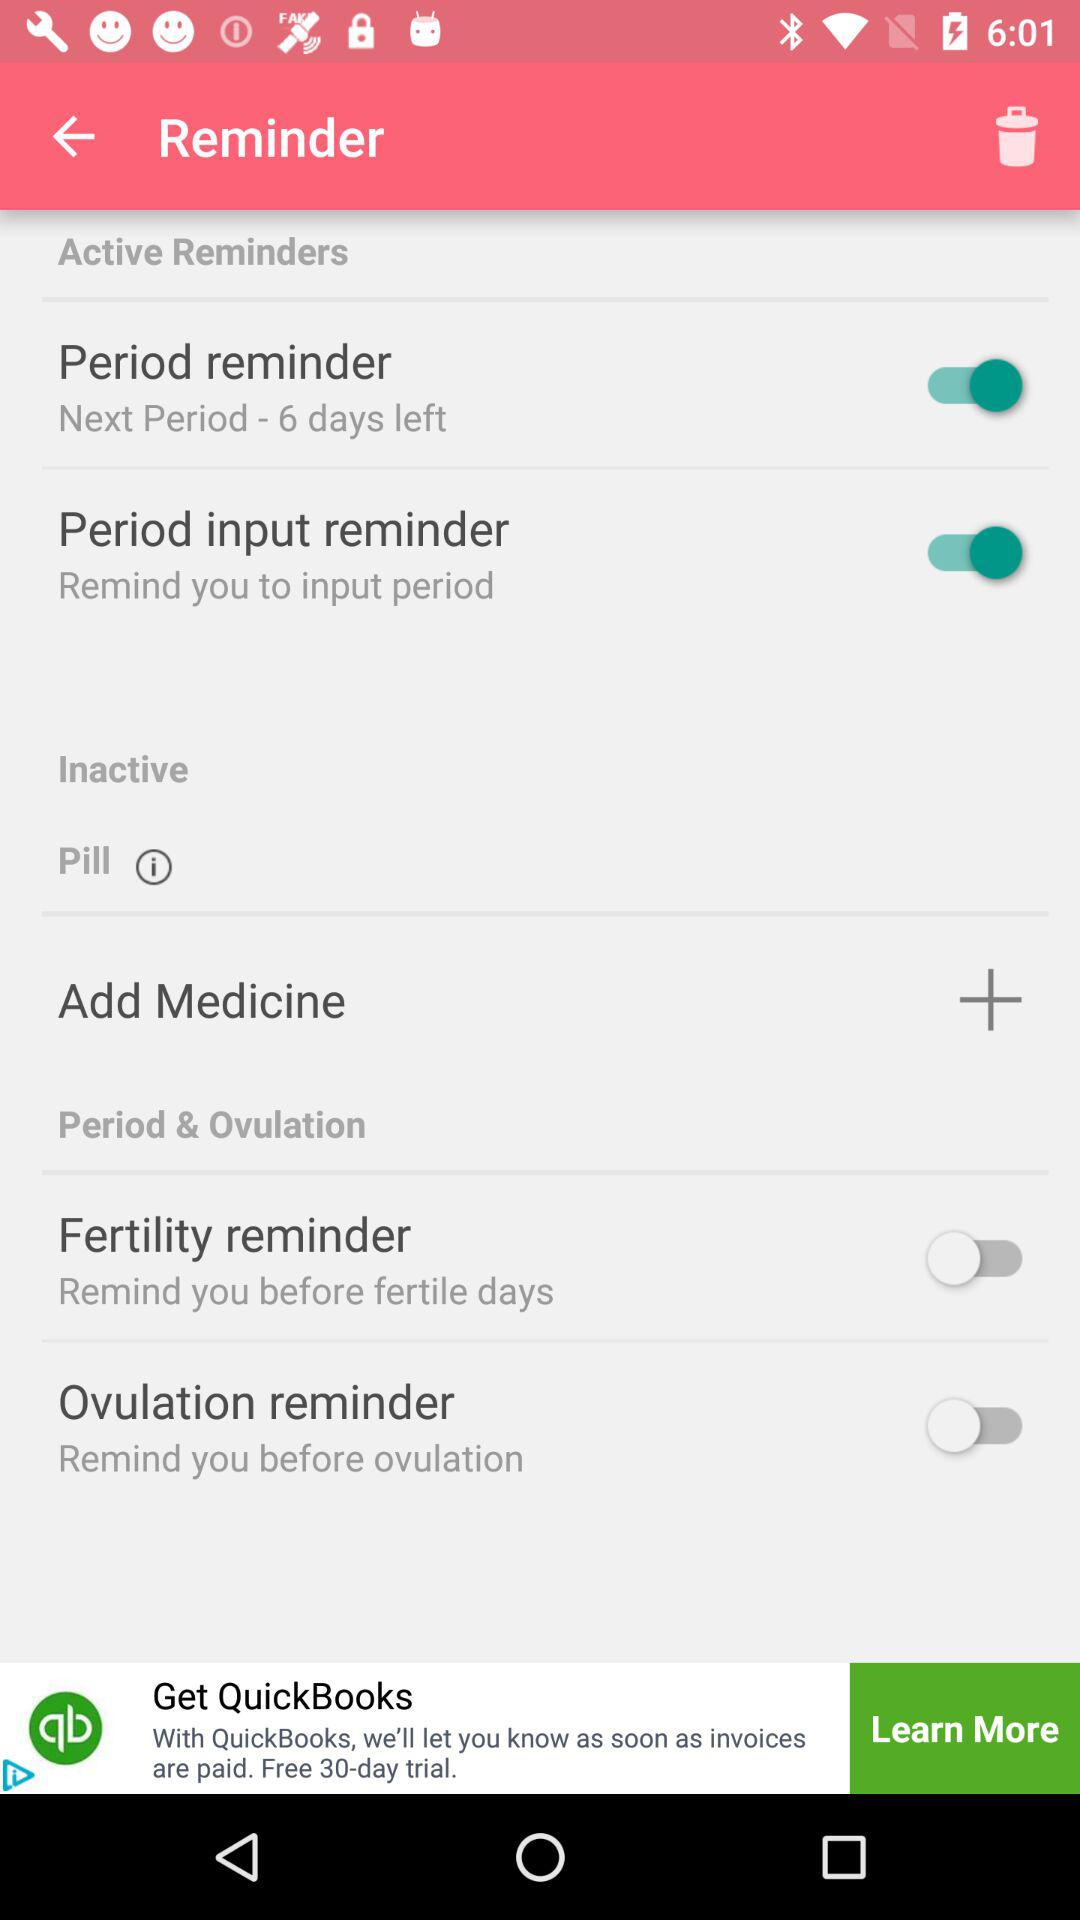What is the status of the "Period input reminder" switch? The status of the "Period input reminder" switch is "on". 